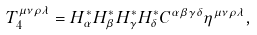Convert formula to latex. <formula><loc_0><loc_0><loc_500><loc_500>T _ { 4 } ^ { \mu \nu \rho \lambda } = H _ { \alpha } ^ { \ast } H _ { \beta } ^ { \ast } H _ { \gamma } ^ { \ast } H _ { \delta } ^ { \ast } C ^ { \alpha \beta \gamma \delta } \eta ^ { \mu \nu \rho \lambda } ,</formula> 